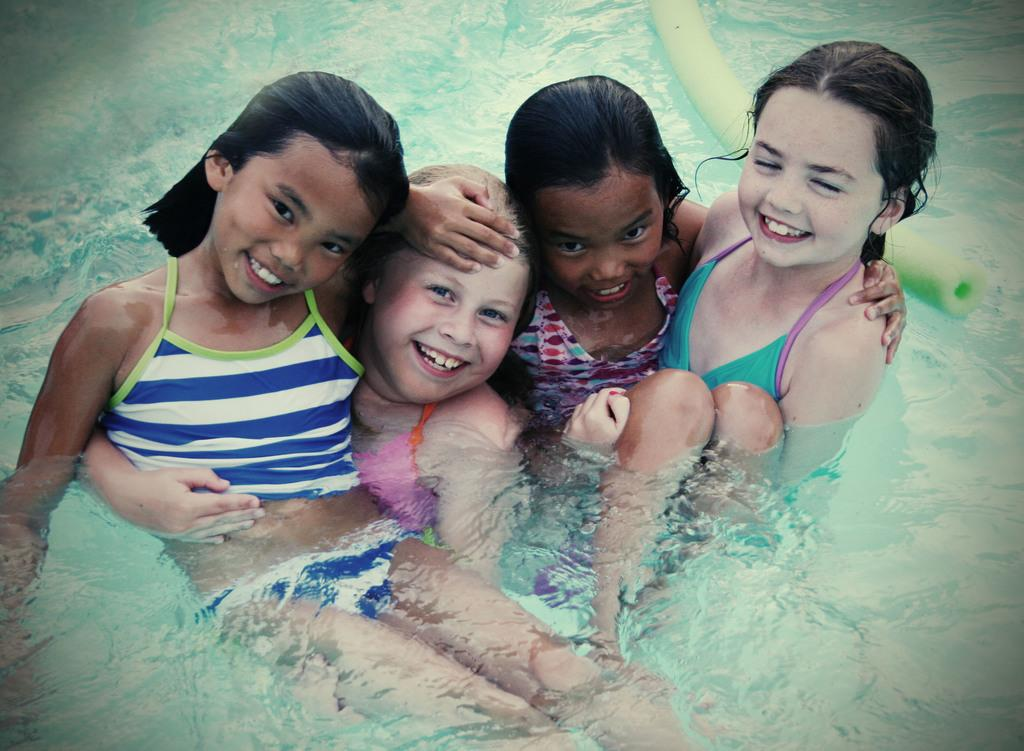How many people are in the image? There are four girls in the image. What is the facial expression of the girls? The girls are smiling. Where are the girls located in the image? The girls are in the water. What can be seen on the water in the image? There is an object on the water. What type of leather collar can be seen on the girls in the image? There is no leather collar present on the girls in the image. How many men are visible in the image? The image does not show any men; it features four girls. 